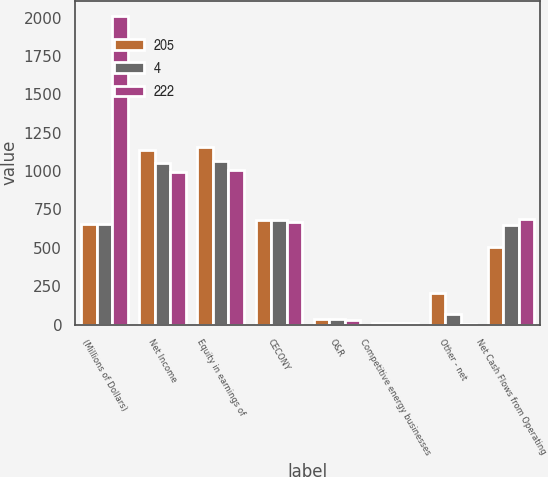Convert chart. <chart><loc_0><loc_0><loc_500><loc_500><stacked_bar_chart><ecel><fcel>(Millions of Dollars)<fcel>Net Income<fcel>Equity in earnings of<fcel>CECONY<fcel>O&R<fcel>Competitive energy businesses<fcel>Other - net<fcel>Net Cash Flows from Operating<nl><fcel>205<fcel>658<fcel>1138<fcel>1154<fcel>682<fcel>34<fcel>11<fcel>208<fcel>503<nl><fcel>4<fcel>658<fcel>1051<fcel>1064<fcel>681<fcel>33<fcel>12<fcel>67<fcel>646<nl><fcel>222<fcel>2010<fcel>992<fcel>1008<fcel>670<fcel>32<fcel>8<fcel>4<fcel>690<nl></chart> 